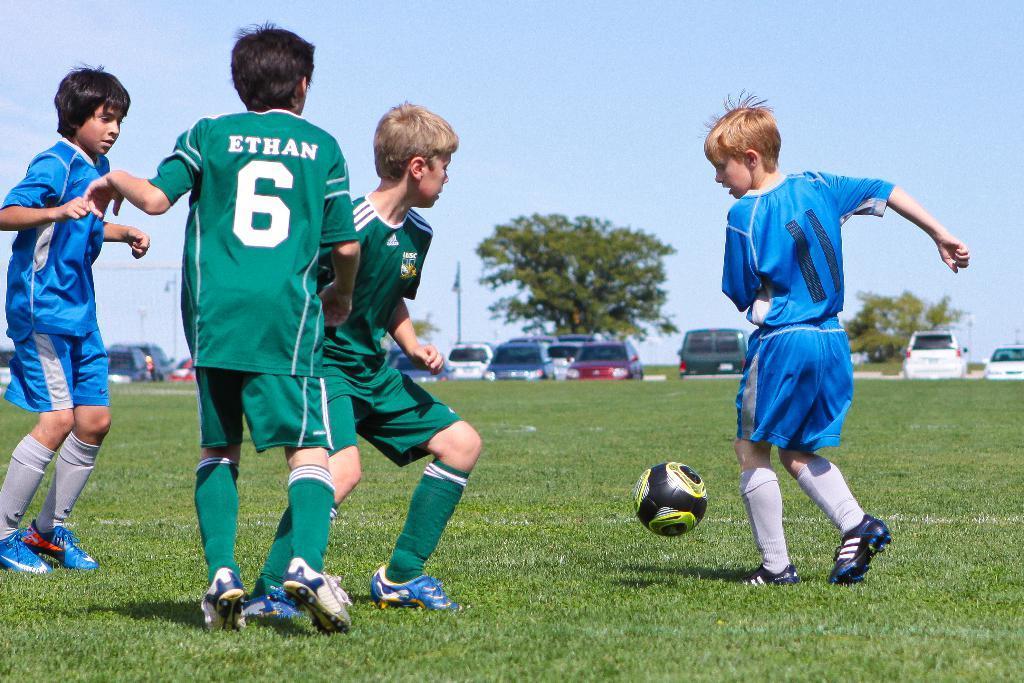In one or two sentences, can you explain what this image depicts? This image consists of four boys. At the bottom, there is green grass on the ground. They are playing football. In the background, there are many cars and trees. At the top, there is sky. 